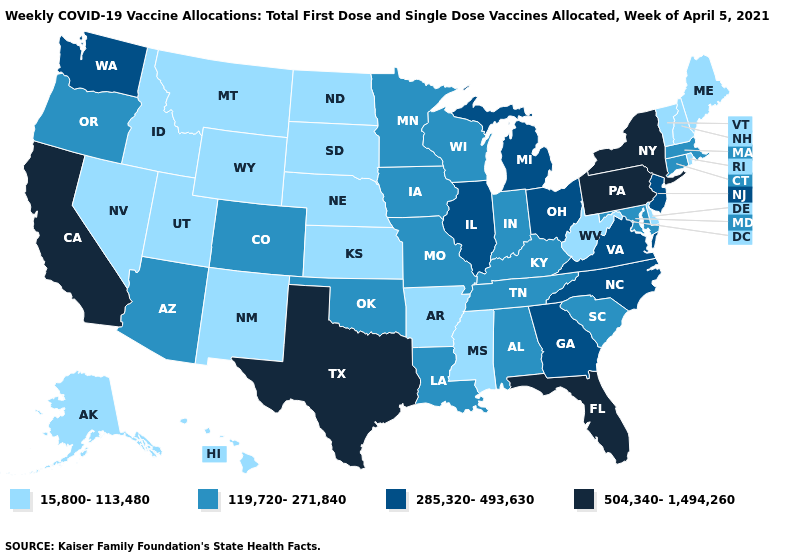Does Idaho have the highest value in the West?
Concise answer only. No. Name the states that have a value in the range 119,720-271,840?
Answer briefly. Alabama, Arizona, Colorado, Connecticut, Indiana, Iowa, Kentucky, Louisiana, Maryland, Massachusetts, Minnesota, Missouri, Oklahoma, Oregon, South Carolina, Tennessee, Wisconsin. Name the states that have a value in the range 504,340-1,494,260?
Quick response, please. California, Florida, New York, Pennsylvania, Texas. What is the value of Wyoming?
Answer briefly. 15,800-113,480. What is the value of Wisconsin?
Quick response, please. 119,720-271,840. Does Wyoming have the highest value in the West?
Short answer required. No. What is the highest value in the USA?
Quick response, please. 504,340-1,494,260. Which states have the lowest value in the MidWest?
Answer briefly. Kansas, Nebraska, North Dakota, South Dakota. What is the lowest value in the South?
Keep it brief. 15,800-113,480. Among the states that border North Dakota , does Minnesota have the lowest value?
Short answer required. No. Does Iowa have the lowest value in the USA?
Write a very short answer. No. Among the states that border Colorado , does Arizona have the highest value?
Short answer required. Yes. Among the states that border Idaho , which have the highest value?
Write a very short answer. Washington. Does Maryland have a lower value than Maine?
Answer briefly. No. Does West Virginia have the lowest value in the USA?
Answer briefly. Yes. 